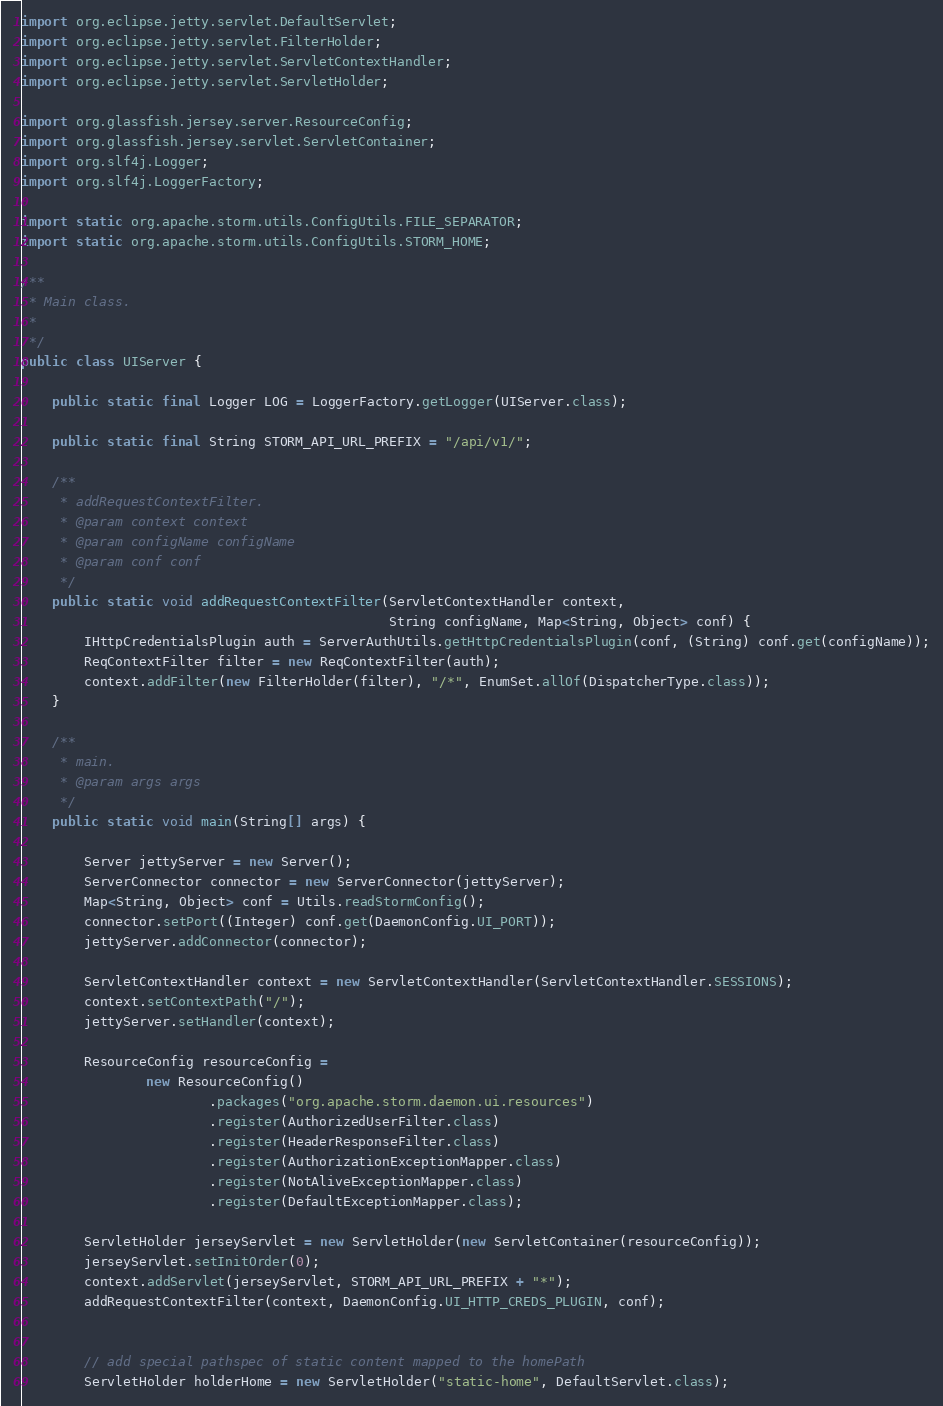Convert code to text. <code><loc_0><loc_0><loc_500><loc_500><_Java_>import org.eclipse.jetty.servlet.DefaultServlet;
import org.eclipse.jetty.servlet.FilterHolder;
import org.eclipse.jetty.servlet.ServletContextHandler;
import org.eclipse.jetty.servlet.ServletHolder;

import org.glassfish.jersey.server.ResourceConfig;
import org.glassfish.jersey.servlet.ServletContainer;
import org.slf4j.Logger;
import org.slf4j.LoggerFactory;

import static org.apache.storm.utils.ConfigUtils.FILE_SEPARATOR;
import static org.apache.storm.utils.ConfigUtils.STORM_HOME;

/**
 * Main class.
 *
 */
public class UIServer {

    public static final Logger LOG = LoggerFactory.getLogger(UIServer.class);

    public static final String STORM_API_URL_PREFIX = "/api/v1/";

    /**
     * addRequestContextFilter.
     * @param context context
     * @param configName configName
     * @param conf conf
     */
    public static void addRequestContextFilter(ServletContextHandler context,
                                               String configName, Map<String, Object> conf) {
        IHttpCredentialsPlugin auth = ServerAuthUtils.getHttpCredentialsPlugin(conf, (String) conf.get(configName));
        ReqContextFilter filter = new ReqContextFilter(auth);
        context.addFilter(new FilterHolder(filter), "/*", EnumSet.allOf(DispatcherType.class));
    }

    /**
     * main.
     * @param args args
     */
    public static void main(String[] args) {

        Server jettyServer = new Server();
        ServerConnector connector = new ServerConnector(jettyServer);
        Map<String, Object> conf = Utils.readStormConfig();
        connector.setPort((Integer) conf.get(DaemonConfig.UI_PORT));
        jettyServer.addConnector(connector);

        ServletContextHandler context = new ServletContextHandler(ServletContextHandler.SESSIONS);
        context.setContextPath("/");
        jettyServer.setHandler(context);

        ResourceConfig resourceConfig =
                new ResourceConfig()
                        .packages("org.apache.storm.daemon.ui.resources")
                        .register(AuthorizedUserFilter.class)
                        .register(HeaderResponseFilter.class)
                        .register(AuthorizationExceptionMapper.class)
                        .register(NotAliveExceptionMapper.class)
                        .register(DefaultExceptionMapper.class);

        ServletHolder jerseyServlet = new ServletHolder(new ServletContainer(resourceConfig));
        jerseyServlet.setInitOrder(0);
        context.addServlet(jerseyServlet, STORM_API_URL_PREFIX + "*");
        addRequestContextFilter(context, DaemonConfig.UI_HTTP_CREDS_PLUGIN, conf);


        // add special pathspec of static content mapped to the homePath
        ServletHolder holderHome = new ServletHolder("static-home", DefaultServlet.class);
</code> 